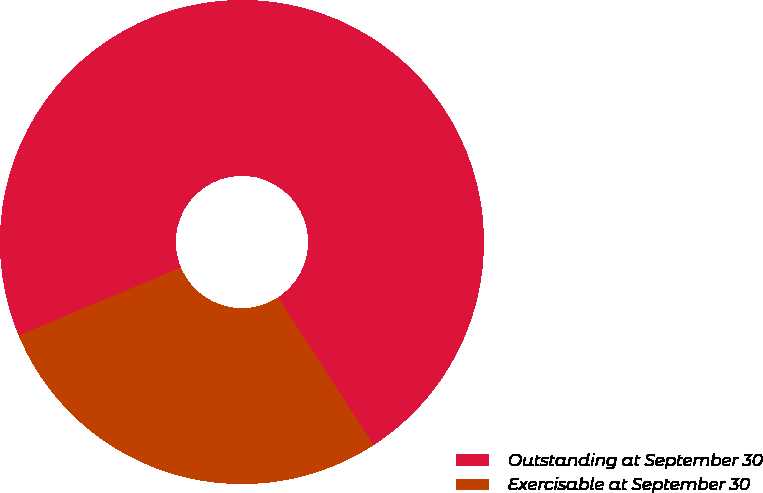Convert chart. <chart><loc_0><loc_0><loc_500><loc_500><pie_chart><fcel>Outstanding at September 30<fcel>Exercisable at September 30<nl><fcel>72.16%<fcel>27.84%<nl></chart> 